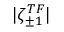<formula> <loc_0><loc_0><loc_500><loc_500>| \zeta _ { \pm 1 } ^ { T F } |</formula> 